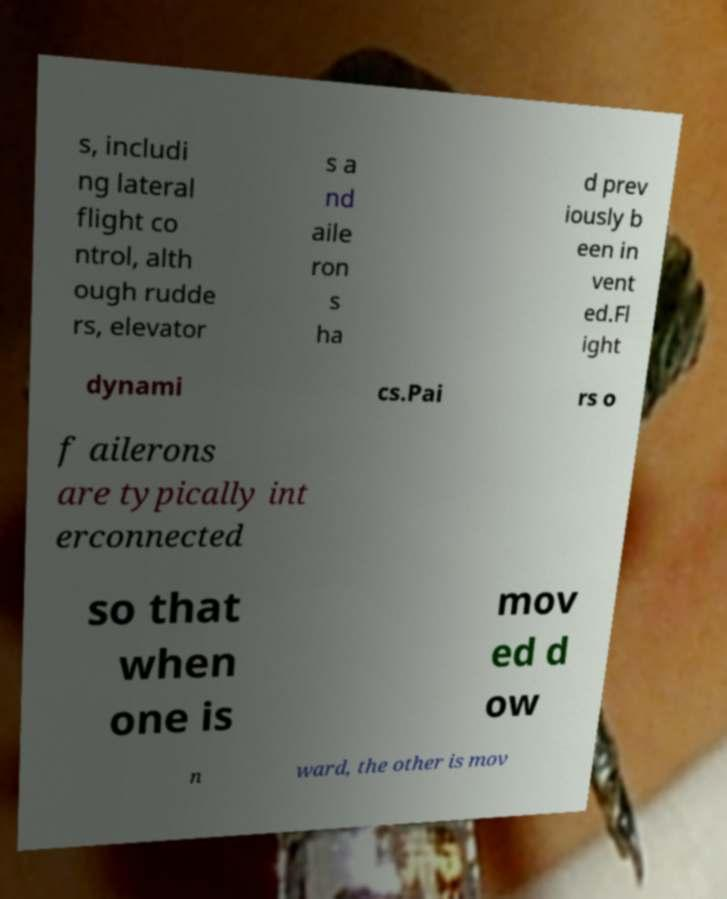What messages or text are displayed in this image? I need them in a readable, typed format. s, includi ng lateral flight co ntrol, alth ough rudde rs, elevator s a nd aile ron s ha d prev iously b een in vent ed.Fl ight dynami cs.Pai rs o f ailerons are typically int erconnected so that when one is mov ed d ow n ward, the other is mov 